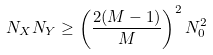<formula> <loc_0><loc_0><loc_500><loc_500>N _ { X } N _ { Y } \geq \left ( \frac { 2 ( M - 1 ) } { M } \right ) ^ { 2 } N _ { 0 } ^ { 2 }</formula> 